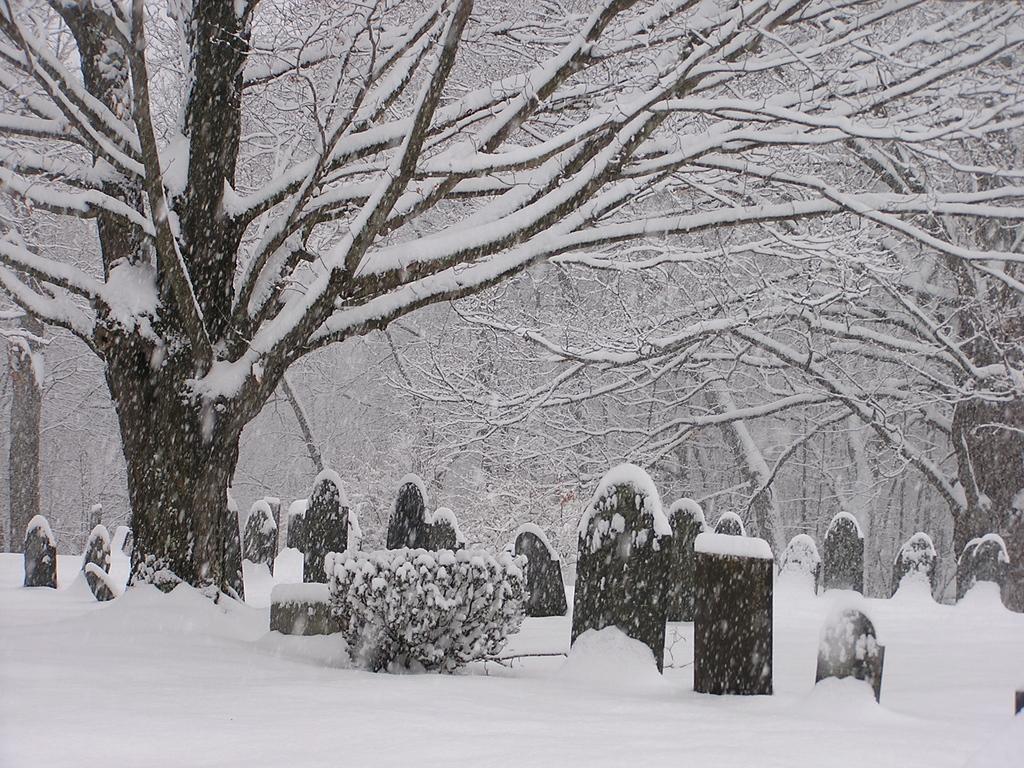Can you describe this image briefly? In this image we can see snow, graveyards, trees and a plant. 